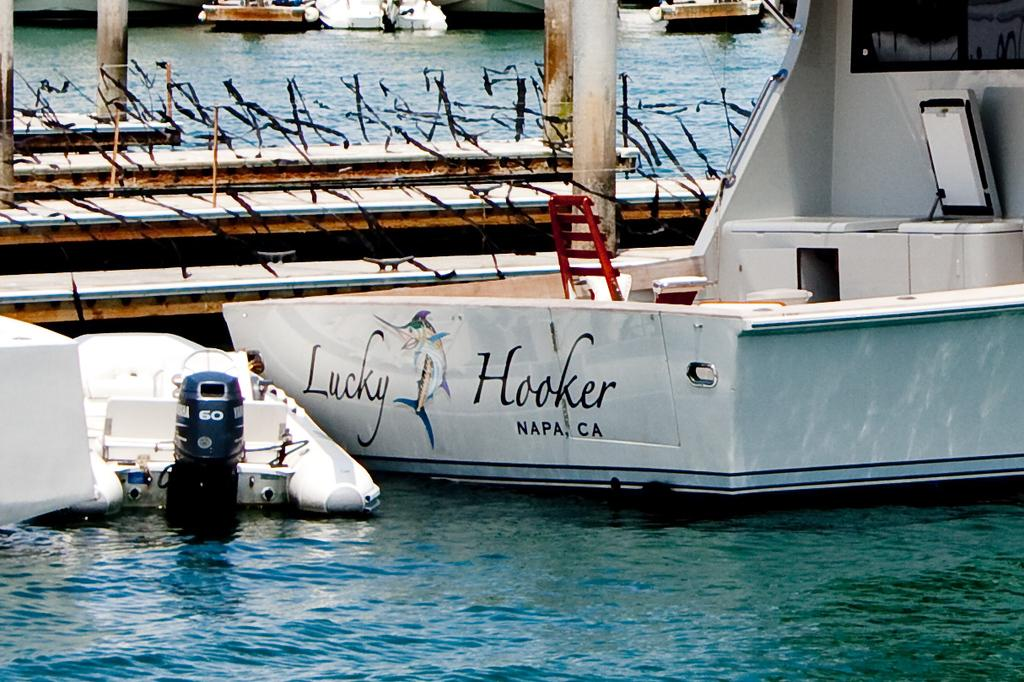What is happening to the boats in the image? The boats are above the water in the image. What else can be seen in the image besides the boats? There are poles visible in the image. Is there any text or markings on any of the boats? Yes, there is writing on one of the boats. What type of feeling does the queen have while observing the invention in the image? There is no queen or invention present in the image; it only features boats above the water and poles. 